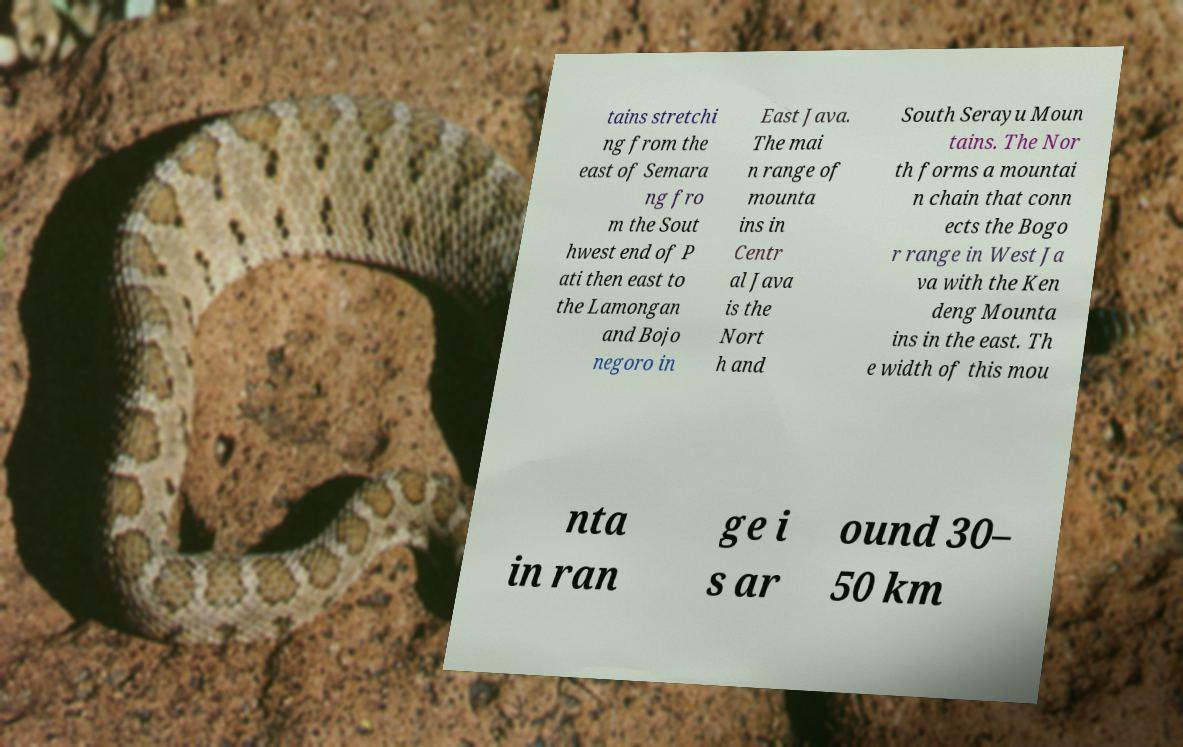There's text embedded in this image that I need extracted. Can you transcribe it verbatim? tains stretchi ng from the east of Semara ng fro m the Sout hwest end of P ati then east to the Lamongan and Bojo negoro in East Java. The mai n range of mounta ins in Centr al Java is the Nort h and South Serayu Moun tains. The Nor th forms a mountai n chain that conn ects the Bogo r range in West Ja va with the Ken deng Mounta ins in the east. Th e width of this mou nta in ran ge i s ar ound 30– 50 km 